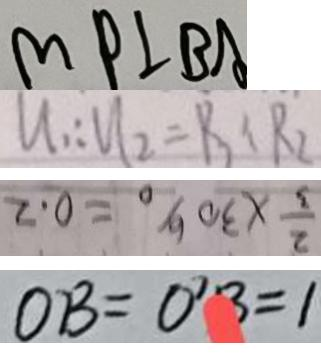Convert formula to latex. <formula><loc_0><loc_0><loc_500><loc_500>M P \bot B A 
 u _ { 1 } : u _ { 2 } = R _ { 3 } : R _ { 2 } 
 \frac { 2 } { 3 } \times 3 0 \% = 0 . 2 
 O B = 0 ^ { 7 } B = 1</formula> 